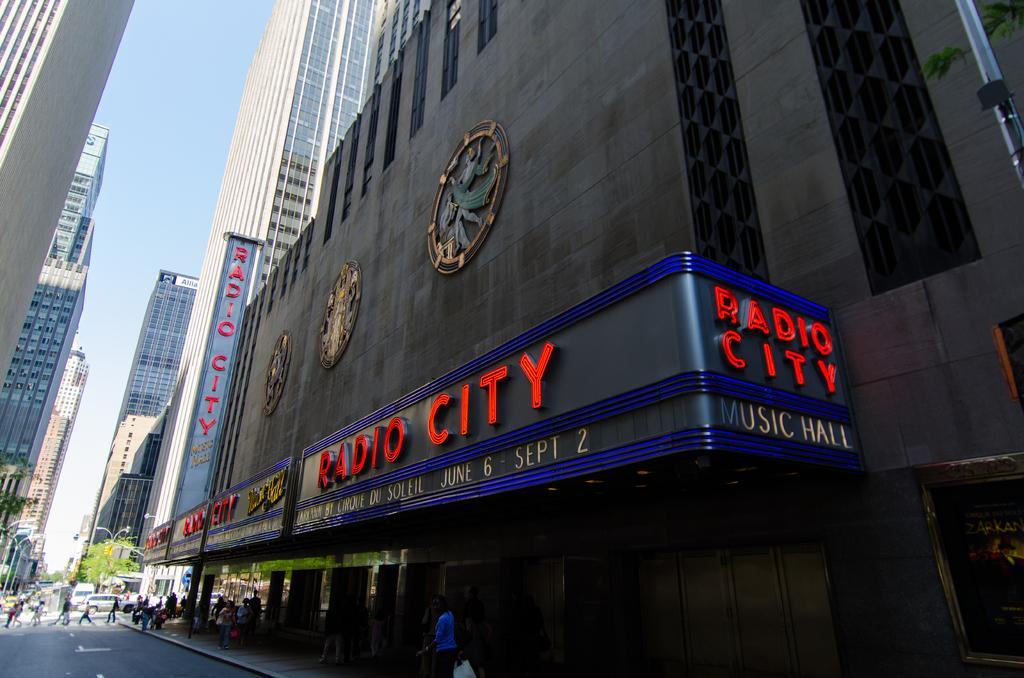What type of structures can be seen in the image? There are buildings in the image. Who or what else is present in the image? There are people and vehicles in the image. What type of vegetation is present in the image? There is a tree in the image. What is visible at the top of the image? The sky is visible at the top of the image. What type of news can be seen on the tree in the image? There is no news present in the image, and the tree does not have any news on it. What type of thrill can be experienced by the people in the image? The provided facts do not mention any specific activity or situation that would cause a thrill for the people in the image. 